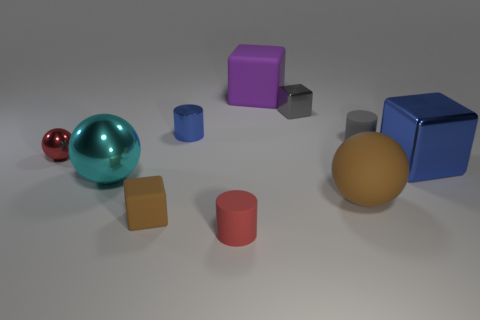The big brown thing has what shape?
Your response must be concise. Sphere. Are there any small rubber objects behind the large matte sphere?
Ensure brevity in your answer.  Yes. Is the small blue cylinder made of the same material as the big cube in front of the tiny shiny cylinder?
Provide a short and direct response. Yes. There is a small red object on the left side of the tiny brown rubber block; does it have the same shape as the cyan thing?
Give a very brief answer. Yes. What number of brown objects are the same material as the red cylinder?
Your response must be concise. 2. How many things are small rubber cylinders to the right of the large purple rubber object or small rubber cylinders?
Ensure brevity in your answer.  2. The red metal sphere is what size?
Your answer should be very brief. Small. The large object that is behind the metallic cylinder left of the big purple rubber block is made of what material?
Your answer should be very brief. Rubber. There is a shiny block that is in front of the gray block; is it the same size as the big purple rubber block?
Your answer should be very brief. Yes. Is there a small metal cylinder of the same color as the big metal cube?
Keep it short and to the point. Yes. 